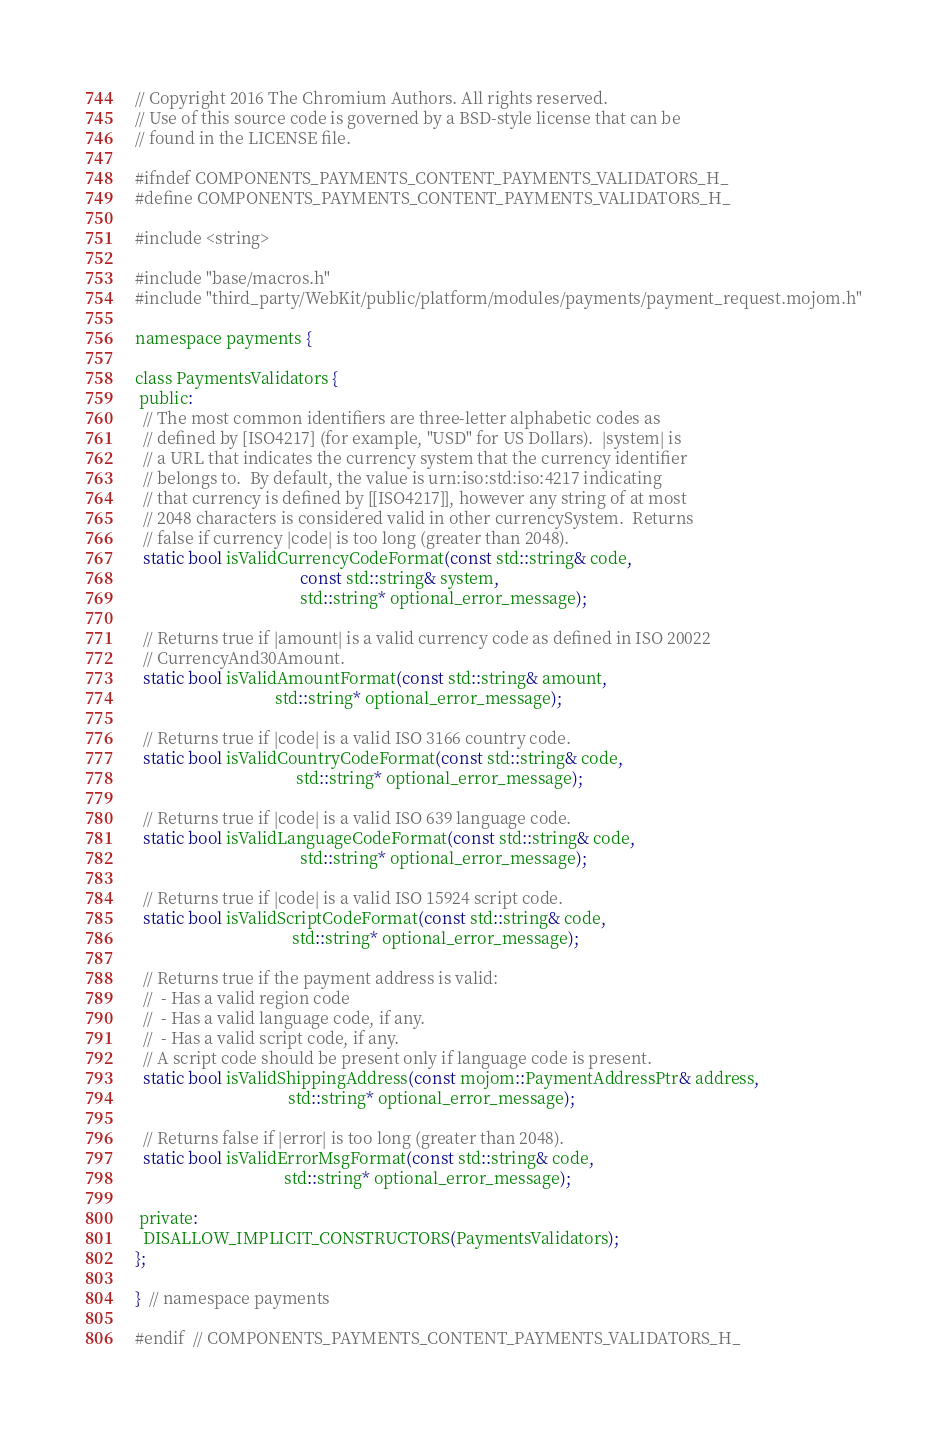<code> <loc_0><loc_0><loc_500><loc_500><_C_>// Copyright 2016 The Chromium Authors. All rights reserved.
// Use of this source code is governed by a BSD-style license that can be
// found in the LICENSE file.

#ifndef COMPONENTS_PAYMENTS_CONTENT_PAYMENTS_VALIDATORS_H_
#define COMPONENTS_PAYMENTS_CONTENT_PAYMENTS_VALIDATORS_H_

#include <string>

#include "base/macros.h"
#include "third_party/WebKit/public/platform/modules/payments/payment_request.mojom.h"

namespace payments {

class PaymentsValidators {
 public:
  // The most common identifiers are three-letter alphabetic codes as
  // defined by [ISO4217] (for example, "USD" for US Dollars).  |system| is
  // a URL that indicates the currency system that the currency identifier
  // belongs to.  By default, the value is urn:iso:std:iso:4217 indicating
  // that currency is defined by [[ISO4217]], however any string of at most
  // 2048 characters is considered valid in other currencySystem.  Returns
  // false if currency |code| is too long (greater than 2048).
  static bool isValidCurrencyCodeFormat(const std::string& code,
                                        const std::string& system,
                                        std::string* optional_error_message);

  // Returns true if |amount| is a valid currency code as defined in ISO 20022
  // CurrencyAnd30Amount.
  static bool isValidAmountFormat(const std::string& amount,
                                  std::string* optional_error_message);

  // Returns true if |code| is a valid ISO 3166 country code.
  static bool isValidCountryCodeFormat(const std::string& code,
                                       std::string* optional_error_message);

  // Returns true if |code| is a valid ISO 639 language code.
  static bool isValidLanguageCodeFormat(const std::string& code,
                                        std::string* optional_error_message);

  // Returns true if |code| is a valid ISO 15924 script code.
  static bool isValidScriptCodeFormat(const std::string& code,
                                      std::string* optional_error_message);

  // Returns true if the payment address is valid:
  //  - Has a valid region code
  //  - Has a valid language code, if any.
  //  - Has a valid script code, if any.
  // A script code should be present only if language code is present.
  static bool isValidShippingAddress(const mojom::PaymentAddressPtr& address,
                                     std::string* optional_error_message);

  // Returns false if |error| is too long (greater than 2048).
  static bool isValidErrorMsgFormat(const std::string& code,
                                    std::string* optional_error_message);

 private:
  DISALLOW_IMPLICIT_CONSTRUCTORS(PaymentsValidators);
};

}  // namespace payments

#endif  // COMPONENTS_PAYMENTS_CONTENT_PAYMENTS_VALIDATORS_H_
</code> 